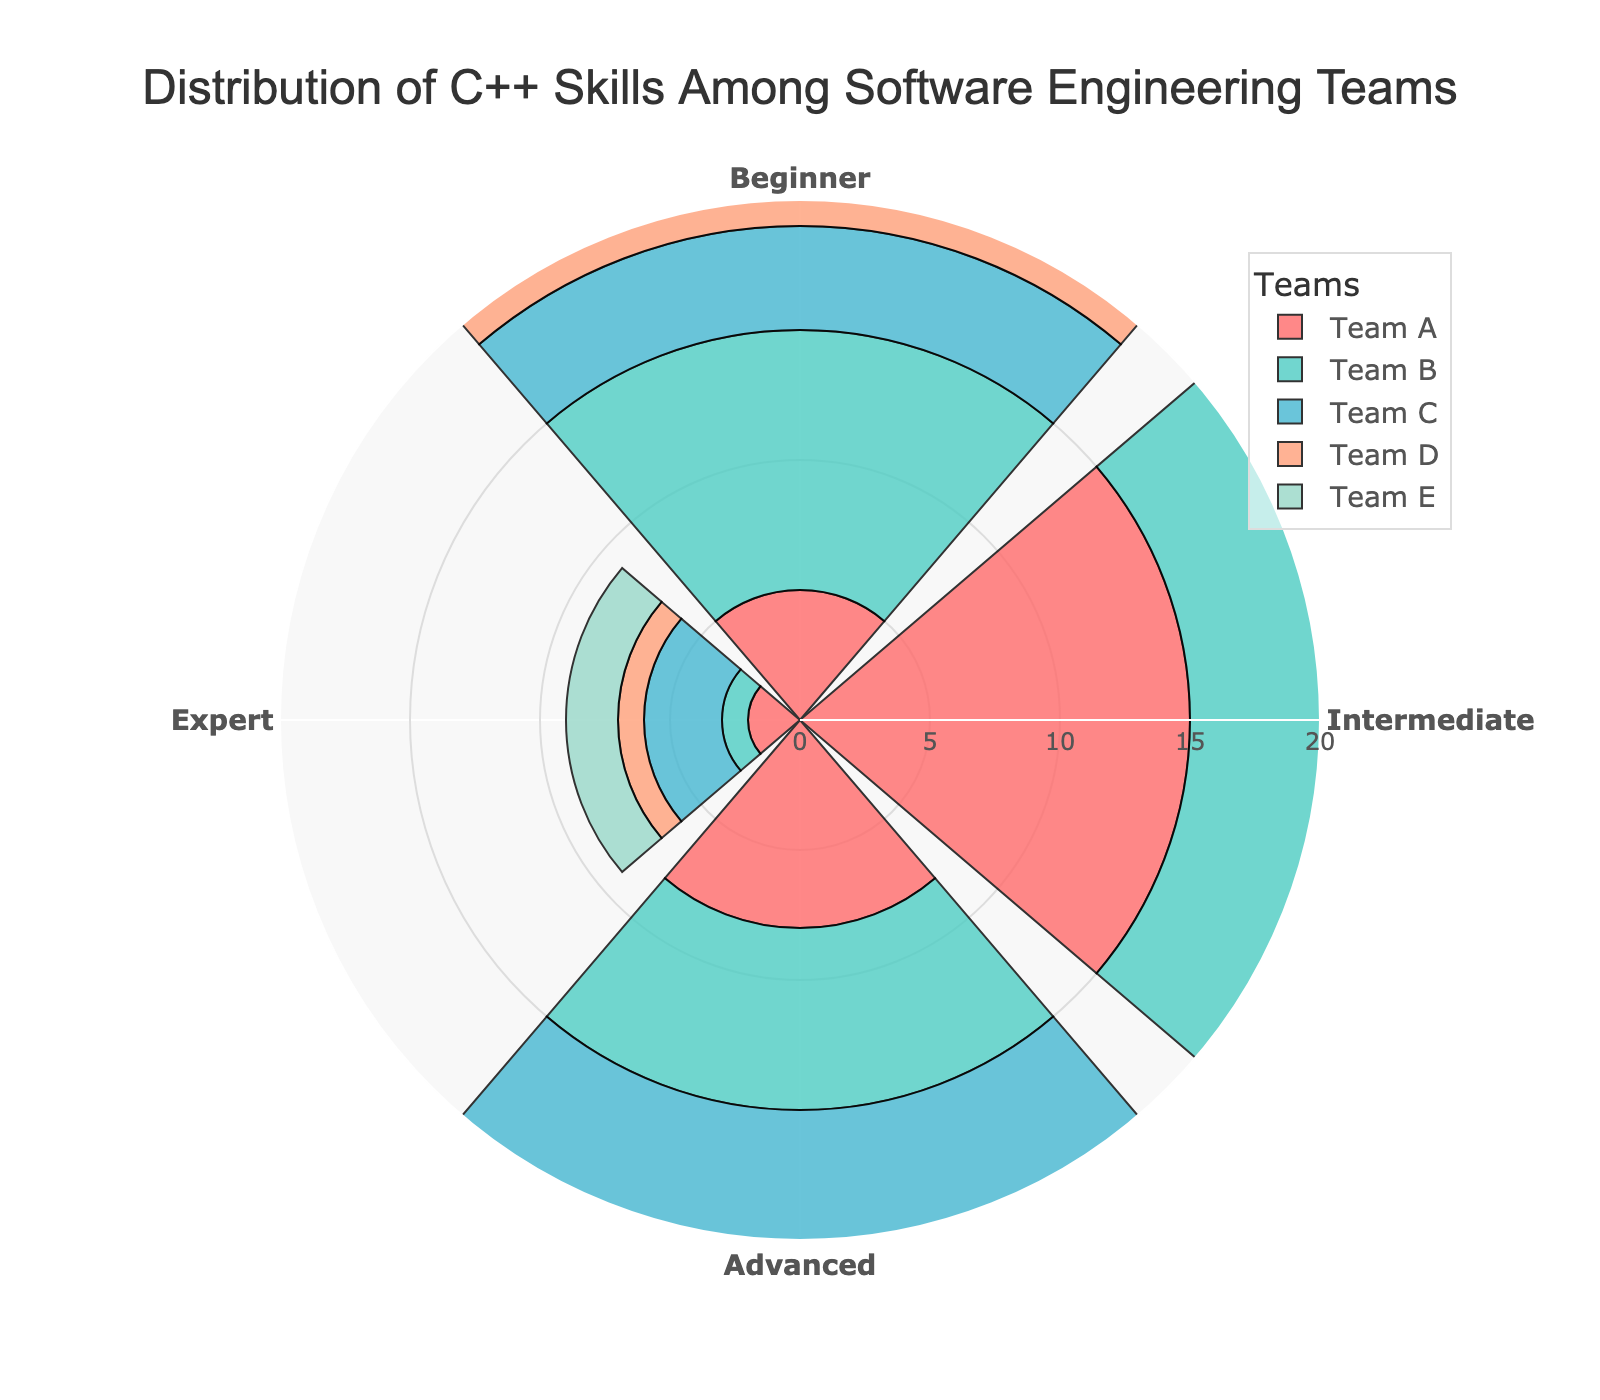What is the title of the chart? The title of the chart is displayed at the top and reads "Distribution of C++ Skills Among Software Engineering Teams".
Answer: Distribution of C++ Skills Among Software Engineering Teams Which team has the highest number of intermediate level members? The bars indicate that Team A has the highest number of intermediate level members with a value of 15.
Answer: Team A How many proficiency levels are shown in the chart? By counting the distinct categories represented on the radial axis, we can see there are 4 proficiency levels: Beginner, Intermediate, Advanced, and Expert.
Answer: 4 Which team has the least number of expert level members? The bar representing Team B has the lowest number of expert level members with a value of 1.
Answer: Team B What is the combined number of advanced level members in Team C and Team D? According to the bars, Team C has 10 advanced level members and Team D has 9 advanced level members. Combined, this sums to 10 + 9 = 19.
Answer: 19 Which proficiency level has the widest range of member distribution across all teams? By visually comparing the spread of the bars, the intermediate level has the widest range with values spanning from 8 to 15.
Answer: Intermediate What is the total number of beginner level members across all teams? Summing up the values for Beginner level members, we get 5 (Team A) + 10 (Team B) + 4 (Team C) + 7 (Team D) + 6 (Team E) = 32.
Answer: 32 In which proficiency level does Team E have the highest number of members? Observing the bars for Team E, the highest bar corresponds to the Intermediate level with 14 members.
Answer: Intermediate How does the number of advanced level members in Team A compare to Team E? Team A has 8 advanced level members while Team E has 5. Therefore, Team A has 3 more advanced level members than Team E.
Answer: 3 more What is the average number of intermediate level members per team? Summing the intermediate level members across all teams gives 15 + 8 + 12 + 10 + 14 = 59. Dividing by 5 teams, the average is 59 / 5 = 11.8.
Answer: 11.8 